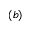Convert formula to latex. <formula><loc_0><loc_0><loc_500><loc_500>( b )</formula> 